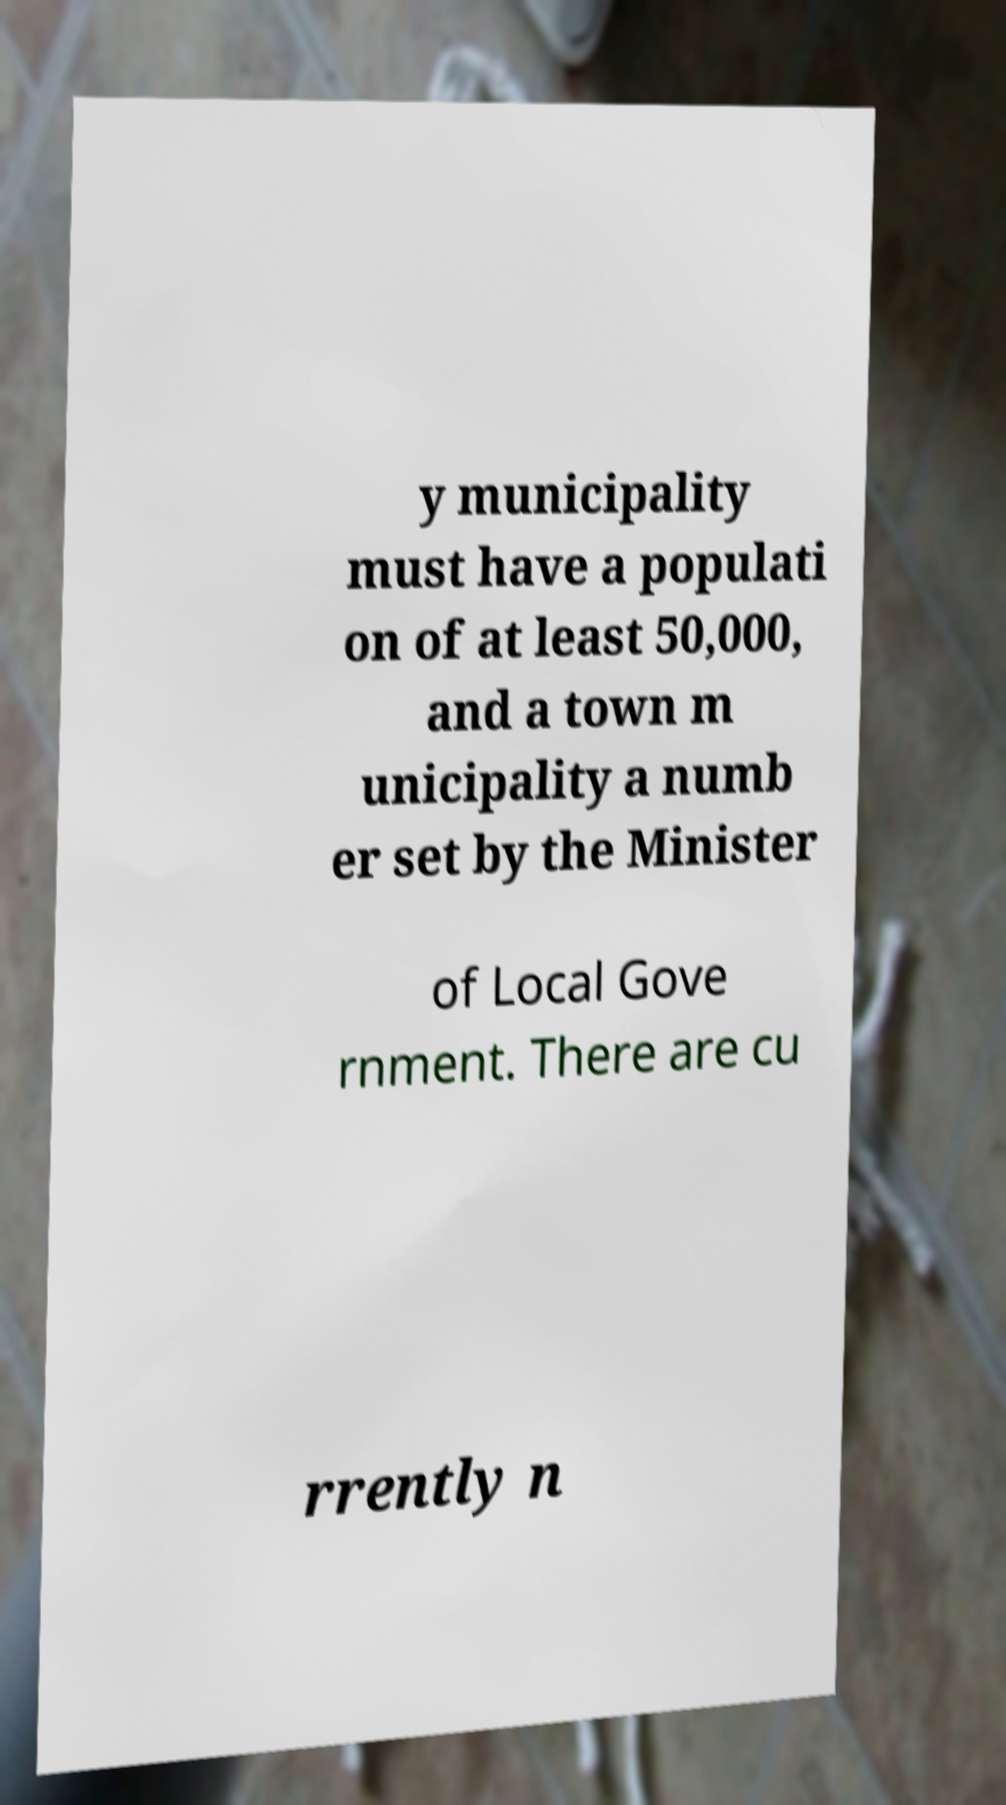Could you assist in decoding the text presented in this image and type it out clearly? y municipality must have a populati on of at least 50,000, and a town m unicipality a numb er set by the Minister of Local Gove rnment. There are cu rrently n 